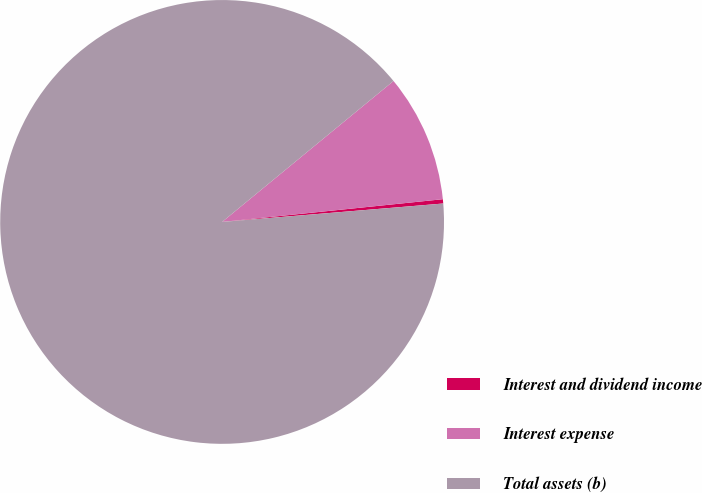Convert chart. <chart><loc_0><loc_0><loc_500><loc_500><pie_chart><fcel>Interest and dividend income<fcel>Interest expense<fcel>Total assets (b)<nl><fcel>0.31%<fcel>9.32%<fcel>90.37%<nl></chart> 